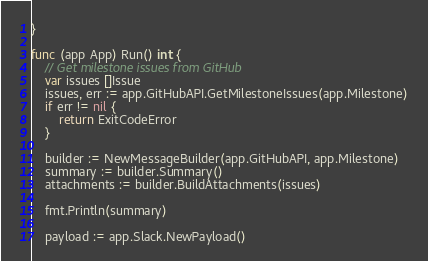Convert code to text. <code><loc_0><loc_0><loc_500><loc_500><_Go_>}

func (app App) Run() int {
	// Get milestone issues from GitHub
	var issues []Issue
	issues, err := app.GitHubAPI.GetMilestoneIssues(app.Milestone)
	if err != nil {
		return ExitCodeError
	}

	builder := NewMessageBuilder(app.GitHubAPI, app.Milestone)
	summary := builder.Summary()
	attachments := builder.BuildAttachments(issues)

	fmt.Println(summary)

	payload := app.Slack.NewPayload()</code> 